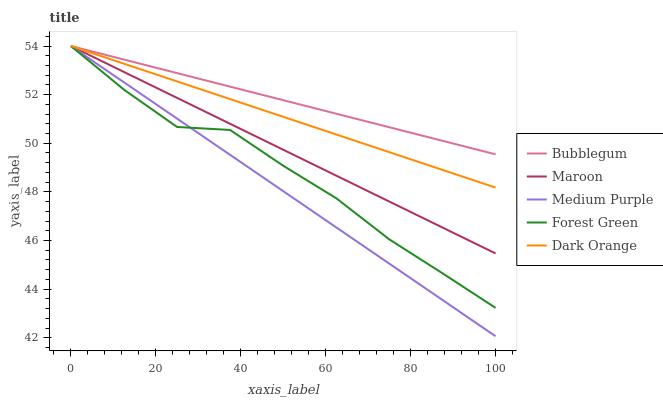Does Medium Purple have the minimum area under the curve?
Answer yes or no. Yes. Does Bubblegum have the maximum area under the curve?
Answer yes or no. Yes. Does Dark Orange have the minimum area under the curve?
Answer yes or no. No. Does Dark Orange have the maximum area under the curve?
Answer yes or no. No. Is Bubblegum the smoothest?
Answer yes or no. Yes. Is Forest Green the roughest?
Answer yes or no. Yes. Is Dark Orange the smoothest?
Answer yes or no. No. Is Dark Orange the roughest?
Answer yes or no. No. Does Medium Purple have the lowest value?
Answer yes or no. Yes. Does Dark Orange have the lowest value?
Answer yes or no. No. Does Bubblegum have the highest value?
Answer yes or no. Yes. Does Maroon intersect Forest Green?
Answer yes or no. Yes. Is Maroon less than Forest Green?
Answer yes or no. No. Is Maroon greater than Forest Green?
Answer yes or no. No. 